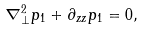Convert formula to latex. <formula><loc_0><loc_0><loc_500><loc_500>\nabla _ { \perp } ^ { 2 } p _ { 1 } + \partial _ { z z } p _ { 1 } = 0 ,</formula> 